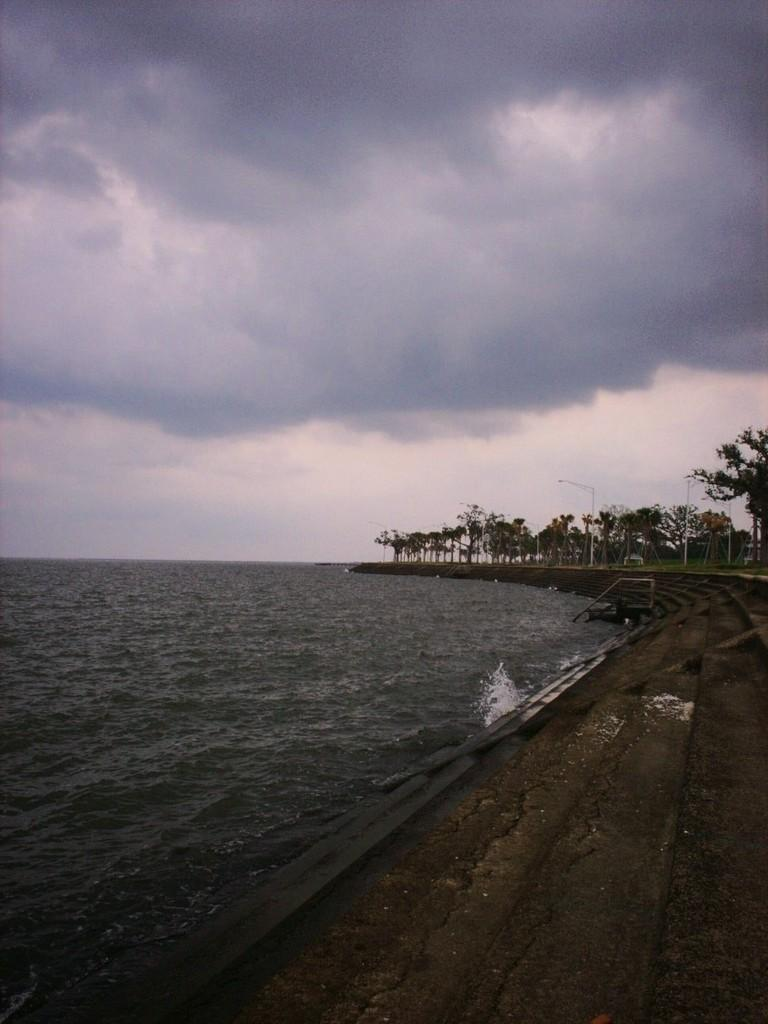What is visible in the image? Water is visible in the image. What can be seen in the background of the image? There are trees and poles in the background of the image. How would you describe the sky in the image? The sky is cloudy in the image. Can you see a guide holding a bulb in the image? There is no guide or bulb present in the image. 